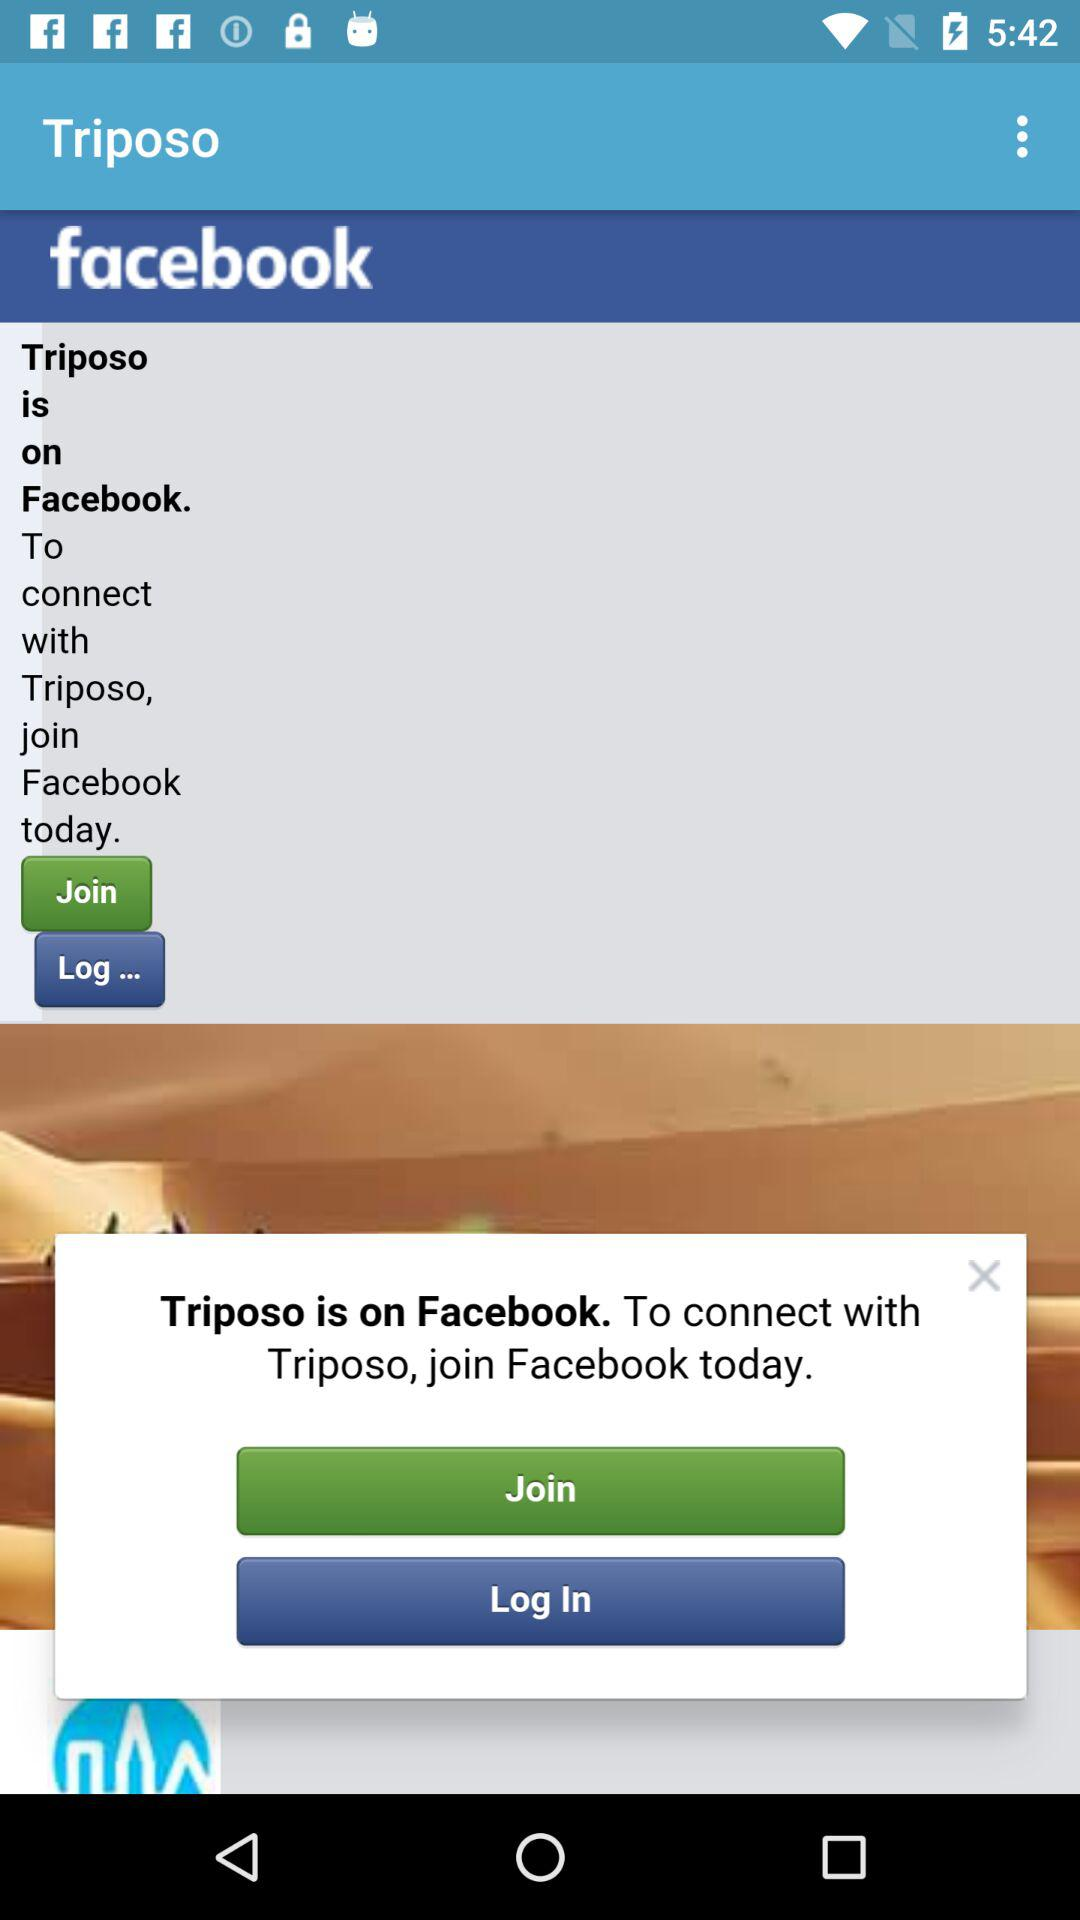What application is on "Facebook"? The application is "Triposo". 